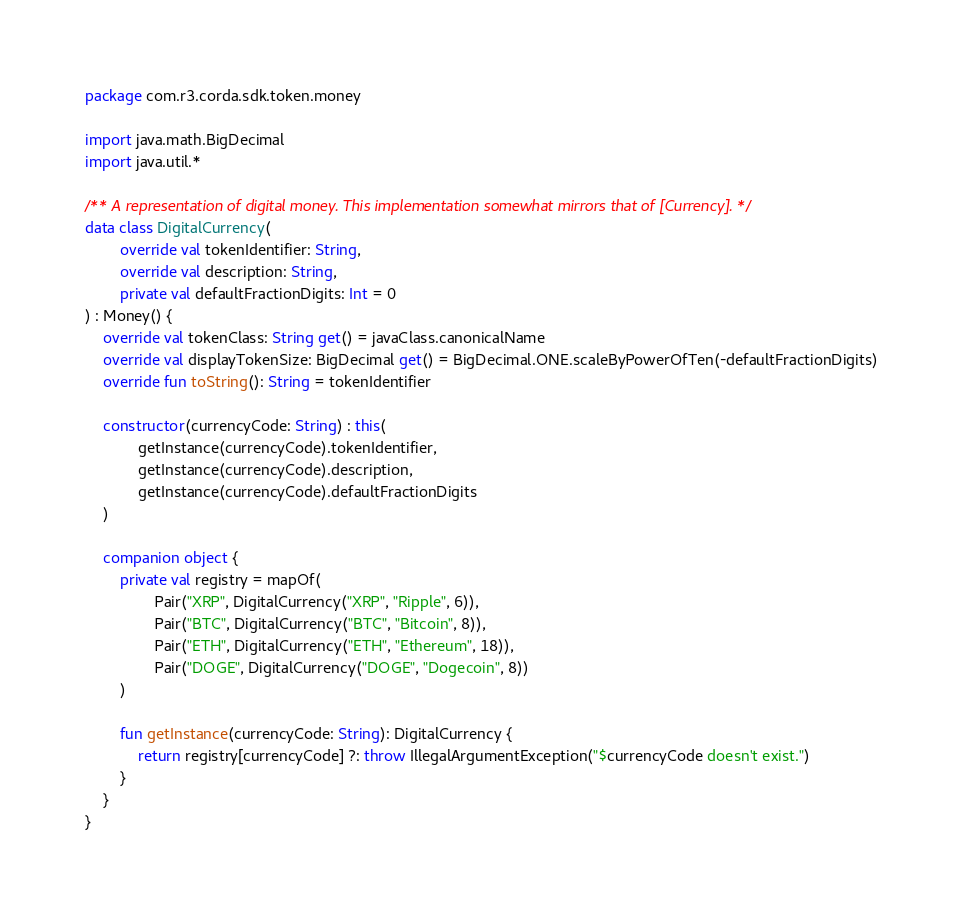<code> <loc_0><loc_0><loc_500><loc_500><_Kotlin_>package com.r3.corda.sdk.token.money

import java.math.BigDecimal
import java.util.*

/** A representation of digital money. This implementation somewhat mirrors that of [Currency]. */
data class DigitalCurrency(
        override val tokenIdentifier: String,
        override val description: String,
        private val defaultFractionDigits: Int = 0
) : Money() {
    override val tokenClass: String get() = javaClass.canonicalName
    override val displayTokenSize: BigDecimal get() = BigDecimal.ONE.scaleByPowerOfTen(-defaultFractionDigits)
    override fun toString(): String = tokenIdentifier

    constructor(currencyCode: String) : this(
            getInstance(currencyCode).tokenIdentifier,
            getInstance(currencyCode).description,
            getInstance(currencyCode).defaultFractionDigits
    )

    companion object {
        private val registry = mapOf(
                Pair("XRP", DigitalCurrency("XRP", "Ripple", 6)),
                Pair("BTC", DigitalCurrency("BTC", "Bitcoin", 8)),
                Pair("ETH", DigitalCurrency("ETH", "Ethereum", 18)),
                Pair("DOGE", DigitalCurrency("DOGE", "Dogecoin", 8))
        )

        fun getInstance(currencyCode: String): DigitalCurrency {
            return registry[currencyCode] ?: throw IllegalArgumentException("$currencyCode doesn't exist.")
        }
    }
}</code> 